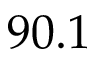<formula> <loc_0><loc_0><loc_500><loc_500>9 0 . 1</formula> 